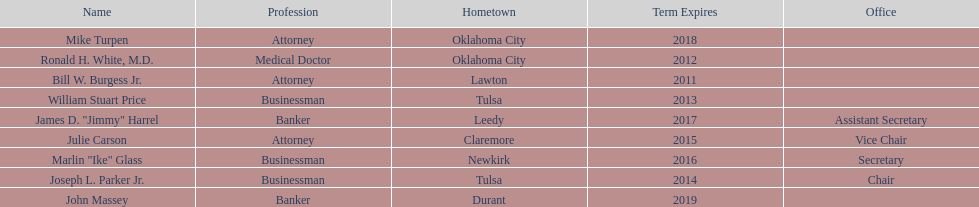Which state regent's term will last the longest? John Massey. 